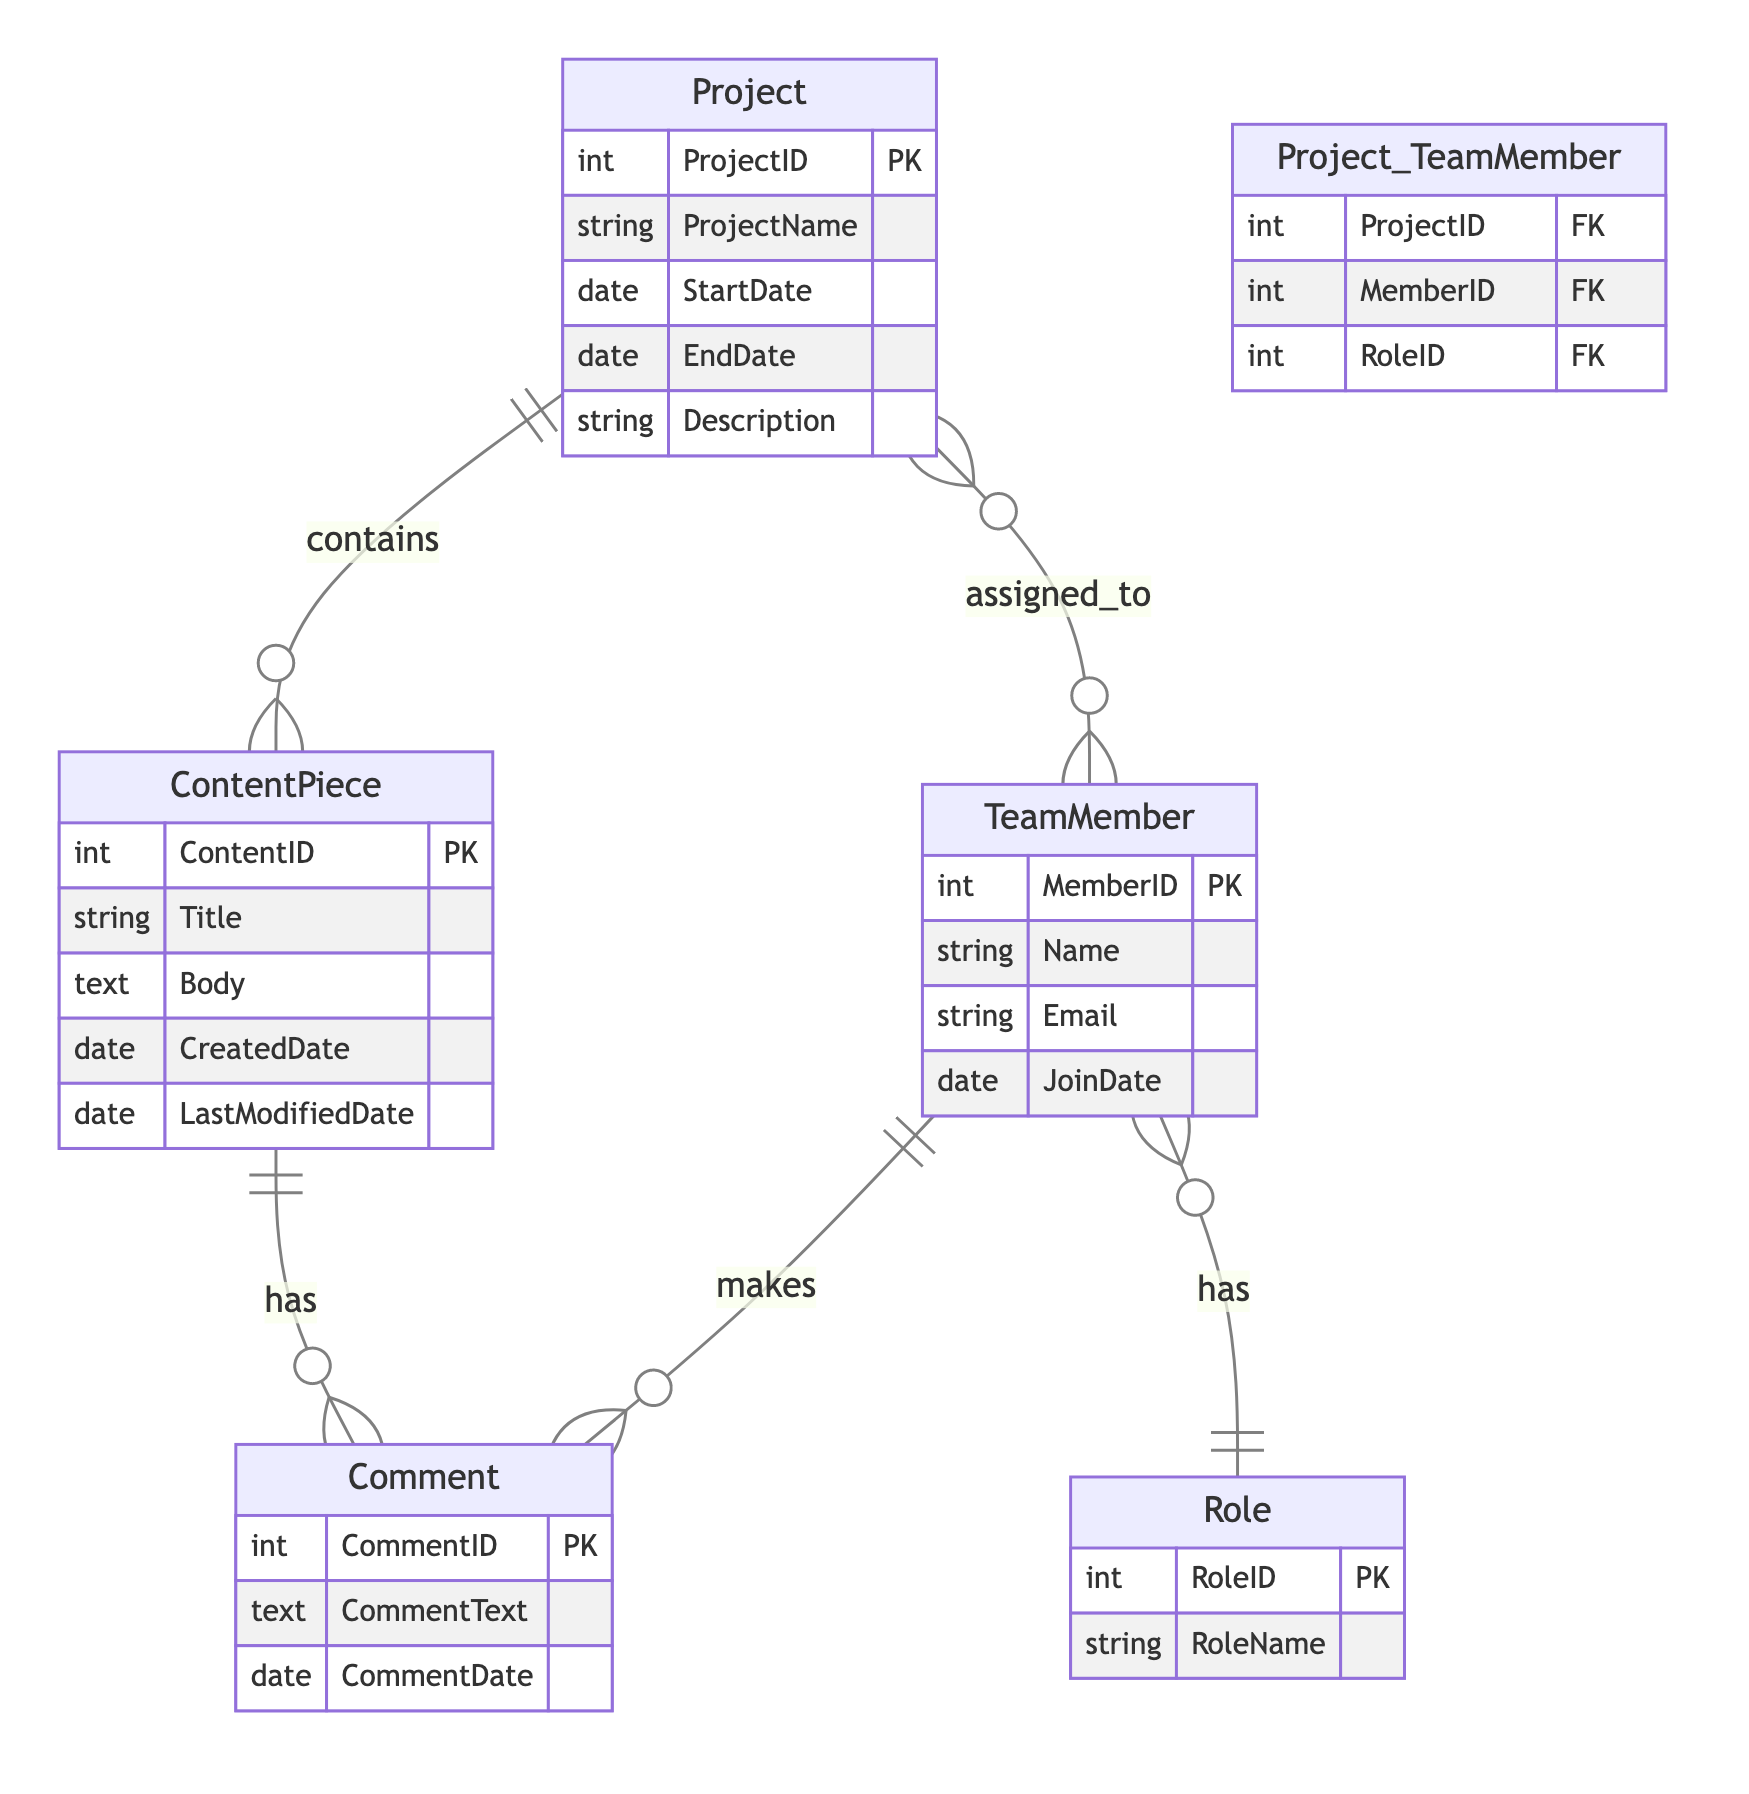What is the primary key of the Project entity? The primary key for the Project entity is ProjectID, which uniquely identifies each project in the system. This can be confirmed by examining the attributes listed under the Project entity in the diagram.
Answer: ProjectID How many attributes does the Role entity have? The Role entity contains two attributes: RoleID and RoleName. This can be established by looking directly at the attributes listed for the Role entity in the diagram.
Answer: Two What type of relationship exists between Project and ContentPiece? The relationship between Project and ContentPiece is one-to-many, meaning that each project can contain multiple content pieces, while each content piece belongs to only one project. This is indicated by the notation in the diagram.
Answer: One-to-many How many roles can a single Team Member have? A single Team Member can have only one role since the relationship between TeamMember and Role is many-to-one, where many team members can have the same role but each member is associated with only one role. This can be inferred from the diagram relationships.
Answer: One Which entity has a relationship with both Comment and Team Member? The entity that has relationships with both Comment and Team Member is the ContentPiece entity because it is connected to Comment (one-to-many) and each comment is made by a Team Member (many-to-one). This is understood by tracing the connections in the diagram.
Answer: ContentPiece What is the maximum number of comments that can be associated with a single ContentPiece? Since the relationship between ContentPiece and Comment is one-to-many, there is no strict limit to the number of comments associated with a single ContentPiece; theoretically, it can be many. This relationship is noted in the diagram.
Answer: Many Which relationship type connects TeamMember with Project? The relationship type that connects TeamMember with Project is many-to-many, indicating that multiple team members can be assigned to multiple projects. This can be clearly seen in the diagram’s relationship annotations.
Answer: Many-to-many What is the foreign key in the Project_TeamMember intersection entity? The foreign keys in the Project_TeamMember intersection entity are ProjectID, MemberID, and RoleID, as they refer back to their respective entities (Project, TeamMember, and Role). This is derived from the attributes specified in the intersection entity of the diagram.
Answer: ProjectID, MemberID, RoleID 